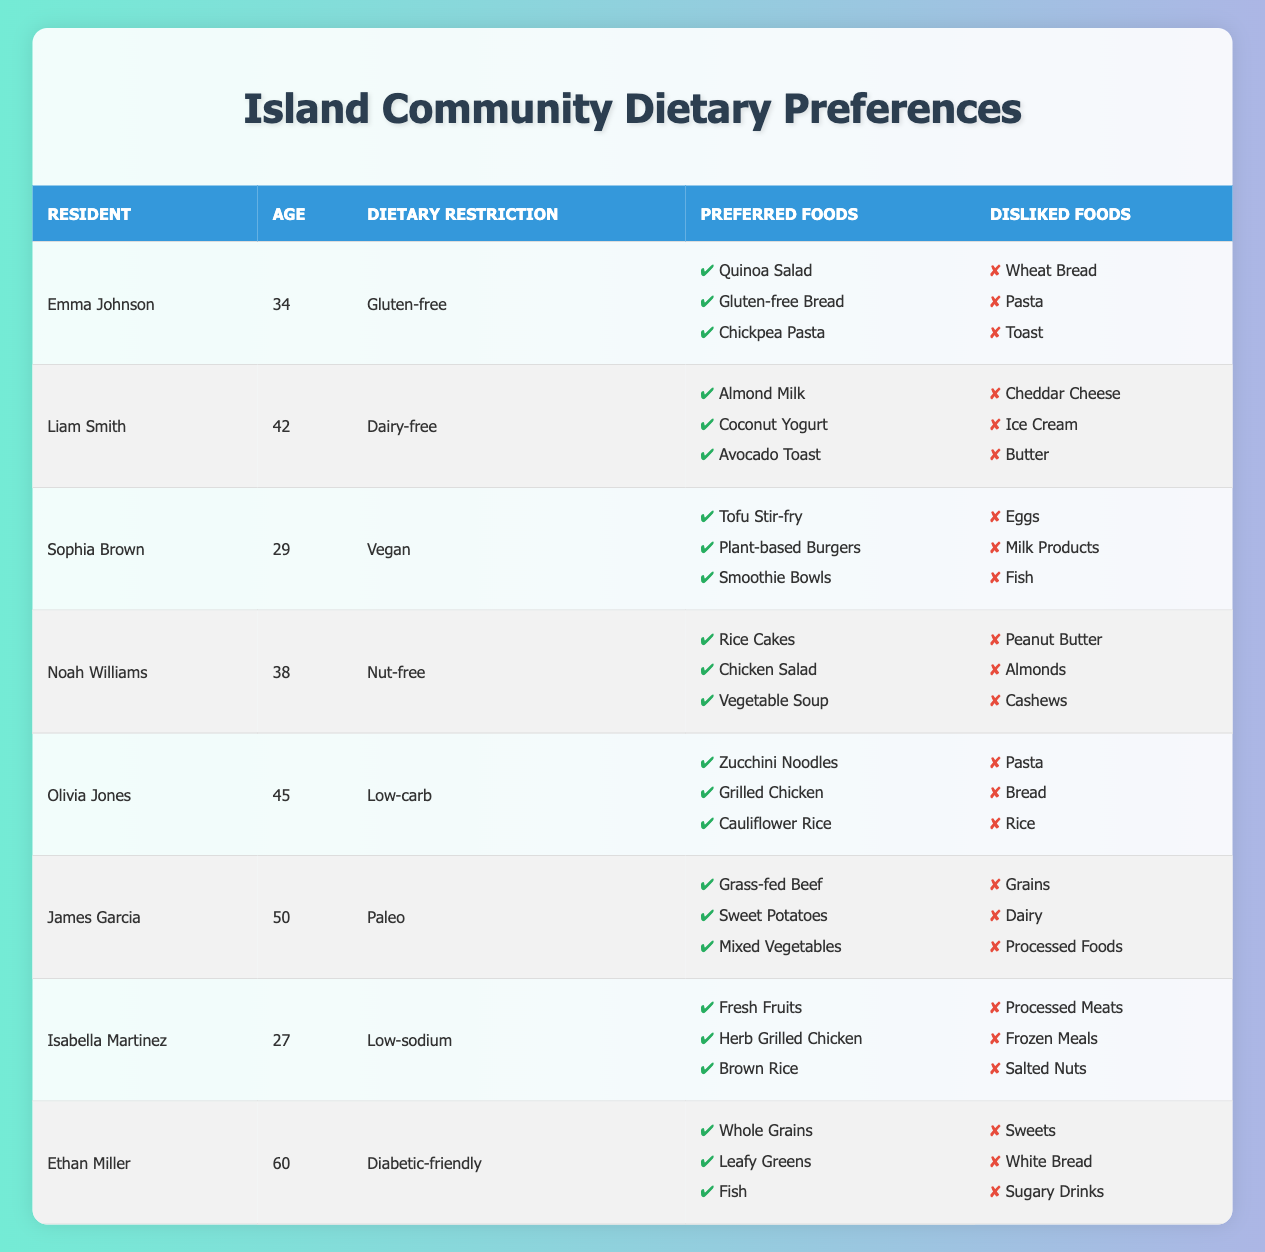What is the dietary restriction of Ethan Miller? Ethan Miller's dietary restriction is listed in the "Dietary Restriction" column of the table, where it specifically states "Diabetic-friendly."
Answer: Diabetic-friendly Which resident dislikes pasta? In the table, both Emma Johnson and Olivia Jones have a dislike for pasta, noted in their "Disliked Foods" lists.
Answer: Emma Johnson and Olivia Jones How many residents prefer gluten-free foods? The table lists Emma Johnson as the only resident with a gluten-free dietary restriction, confirming that only one resident prefers gluten-free foods.
Answer: 1 Is there any resident aged over 50 who follows a dairy-free diet? In the table, Liam Smith follows a dairy-free diet and is 42 years old, while Ethan Miller, who is over 50, follows a diabetic-friendly diet. Therefore, no resident over 50 follows a dairy-free diet.
Answer: No What is the combined age of all residents with a low-carb dietary restriction? There is one resident with a low-carb dietary restriction (Olivia Jones, aged 45). Since there is only one resident, the combined age is simply Olivia's age.
Answer: 45 How many different dietary restrictions are represented in the table? Upon examining the table, there are eight different dietary restrictions for the residents: gluten-free, dairy-free, vegan, nut-free, low-carb, paleo, low-sodium, and diabetic-friendly, summing up to eight distinct types.
Answer: 8 Do any of the residents prefer fish? Ethan Miller's preference for fish is indicated in his "Preferred Foods" listed in the table, confirming that one resident prefers fish.
Answer: Yes What is the most common disliked food among residents? By reviewing the "Disliked Foods" column, no food item appears more than once across the residents' lists, indicating that there is no single most common disliked food.
Answer: None 